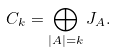<formula> <loc_0><loc_0><loc_500><loc_500>C _ { k } = \bigoplus _ { | A | = k } J _ { A } .</formula> 